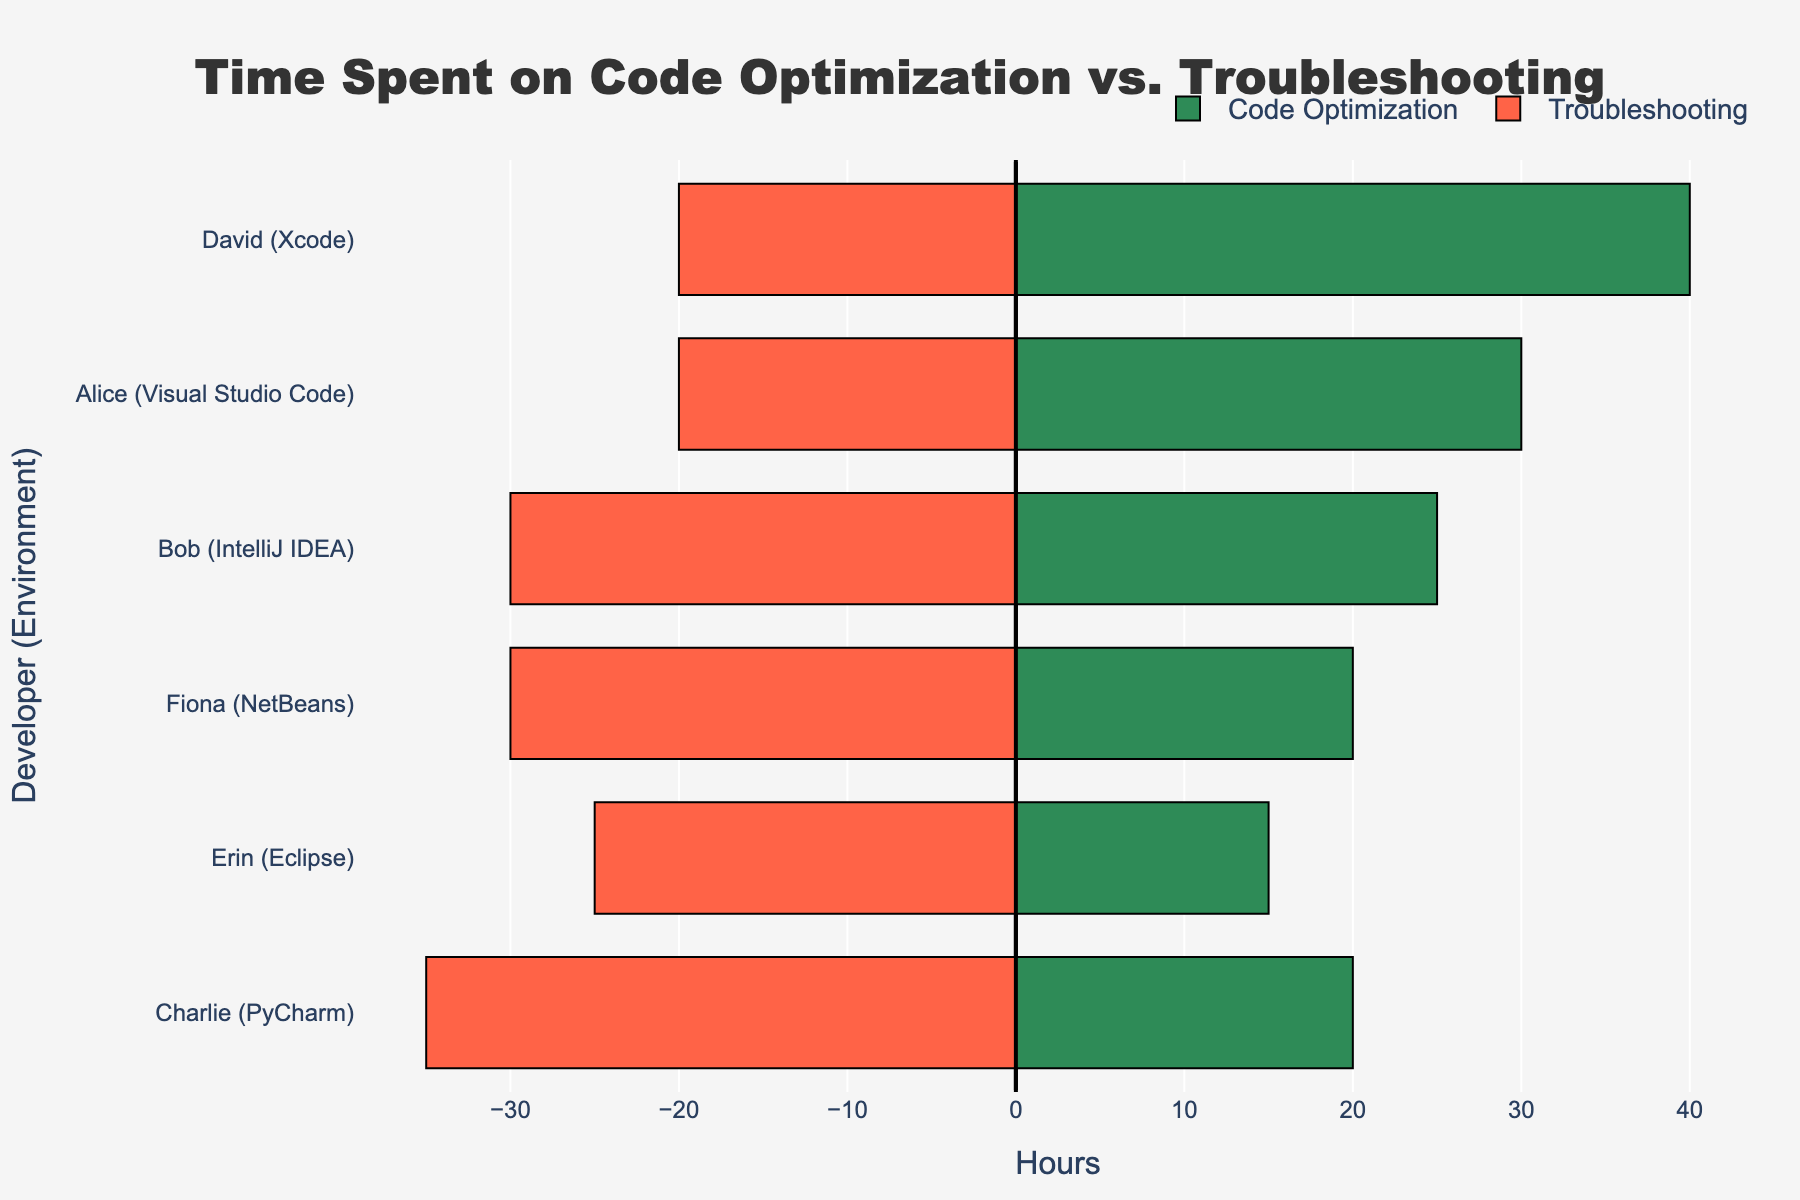Which developer spent the most time on code optimization in Xcode? Look for the bars colored in green that represent code optimization for developers using Xcode environment. Identify the highest bar for Xcode and note the developer associated with it.
Answer: David By how many hours does Charlie spend more on troubleshooting than code optimization in PyCharm? Locate Charlie under PyCharm environment and identify the green (code optimization) and red (troubleshooting) bars for him. Find the difference between the values of the red and green bars.
Answer: 15 Which developer had the smallest difference in hours spent between code optimization and troubleshooting? Check the data for each developer and calculate the absolute difference between code optimization and troubleshooting hours. Identify the smallest difference and the associated developer.
Answer: Erin How does the time Alice spent on troubleshooting in Visual Studio Code compare to the time Bob spent on code optimization in IntelliJ IDEA? Locate the bars for Alice and Bob in their respective environments. Compare the height of Alice's red bar (troubleshooting) to Bob's green bar (code optimization).
Answer: Alice spent less time (20 hours vs. 25 hours) What's the total time spent on code optimization by Bob and Erin combined? Add the green bar values for Bob and Erin. Bob spent 25 hours and Erin spent 15 hours on code optimization. Summing these values gives the total.
Answer: 40 Which environment has developers with the greatest variance between code optimization and troubleshooting times? Calculate the differences between code optimization and troubleshooting times for each developer in each environment. Identify the environment with the highest observed differences.
Answer: PyCharm How many developers spent more hours on troubleshooting than on code optimization? Compare the length of the green (code optimization) and red (troubleshooting) bars for each developer. Count the number of developers where the red bar is longer.
Answer: 3 What's the average time spent on code optimization across all developers? Sum the hours spent on code optimization by all developers and divide by the number of developers. (30 + 25 + 20 + 40 + 15 + 20) / 6 results in the average.
Answer: 25 